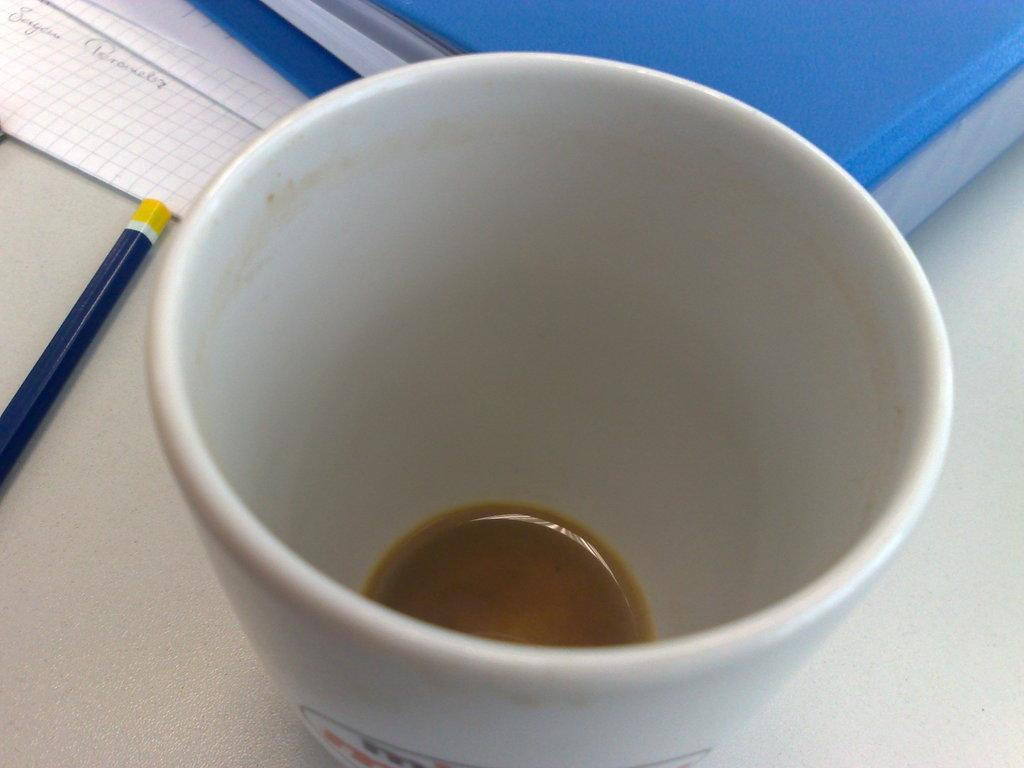What type of dishware is present in the image? There is a tea cup in the image. What stationery item can be seen in the image? There is a pencil in the image. What type of document storage is visible in the image? There is a file in the image. What type of paper items are present in the image? There are papers in the image. What is the color of the table in the image? The table is white. How many oranges are on the table in the image? There are no oranges present in the image. What type of quiver is visible in the image? There is no quiver present in the image. 